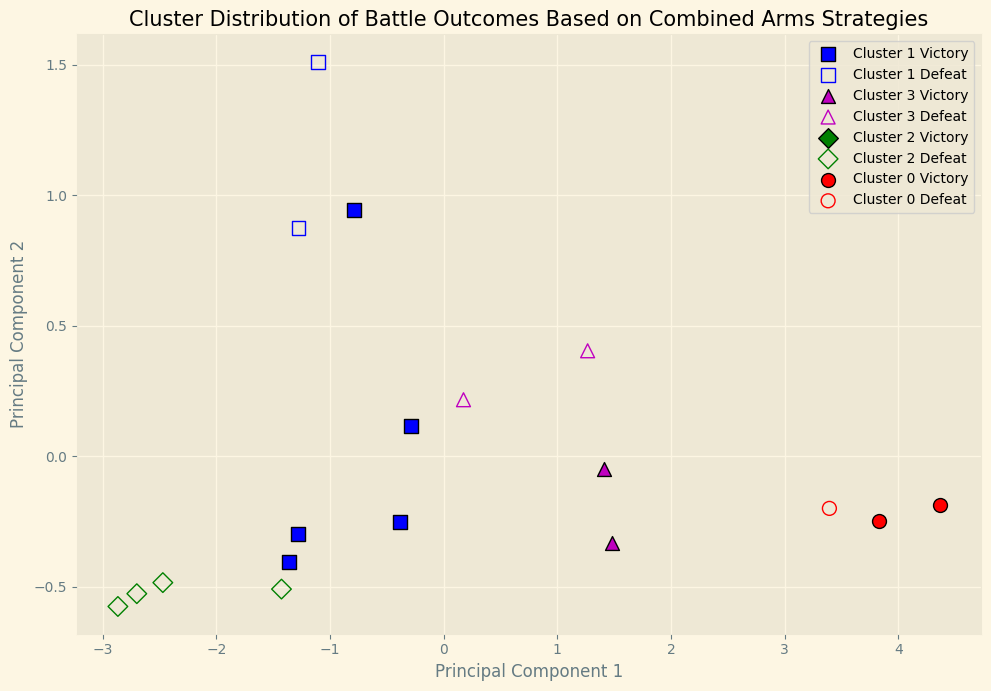What strategy is most frequently associated with victories in Cluster 0? The scatter plot markers and colors show us the distribution of outcomes across clusters. To answer, we examine which strategy is associated with the Cluster 0 Victory markers (ferrous color with solid markers in the example). By checking the cluster's markers, it is apparent.
Answer: Maneuver Warfare Which cluster contains the most "Defeat" outcomes? By visually comparing the number of 'Defeat' markers (those with white centers) in each cluster, we identify that some clusters have more 'Defeat' outcomes than others. The specific count can be observed from the visual plot distribution.
Answer: Cluster 3 What is the relationship between principal components for victories in Strategy "Maneuver Warfare"? To determine the relationship, look at the positions of Maneuver Warfare victory markers. Markers for "Maneuver Warfare" have specific positions in the PCA plot, showing how they align along the two principal components. This can suggest tendencies or clusters that align victories with this strategy.
Answer: Clustering towards higher principal component 1 Compare the number of victories associated with "Frontal Assault" to those with "Defensive Stand". By comparing visual markers for both strategies and tallying their count with their respective outcomes, particularly looking at the scatter plot for 'Victory' markers.
Answer: Frontal Assault has more victories What color indicates the dominant strategy cluster involving "Guerrilla Tactics"? Identify the color associated with the cluster containing the majority of "Guerrilla Tactics" markers, focusing on their cluster colors in the PCA plot.
Answer: Color blue How do the "Defeat" outcomes in the "Breakthrough" strategy compare across principal components? Check the plot for the specific markers assigned to "Breakthrough" strategy 'Defeat' outcomes, noting their positions along the principal component axes. This correlates the spread of these outcomes.
Answer: Spread out across principal component 1 and 2 Is there any cluster with mixed outcomes for "Encirclement" strategy and which one? Determine which, if any, clusters contain both 'Victory' and 'Defeat' markers for the "Encirclement" strategy by analyzing the cluster-wise distribution of outcomes.
Answer: Cluster 2 Do victories in "Maneuver Warfare" occupy a distinct area in the PCA plot compared to defeats? Compare the spatial arrangement of 'Victory' markers to 'Defeat' markers for "Maneuver Warfare" in the PCA plot, noting clustering tendencies and overlaps or separations.
Answer: Yes, distinctively higher Which principal component shows more variance for victories in "Defensive Stand"? Observe the concentration and spread of 'Victory' markers for the "Defensive Stand" strategy along the axes of principal components to identify which component shows a greater range of variance.
Answer: Principal Component 2 What is the noticeable pattern in outcomes for "Frontal Assault" strategy in the PCA plot? By examining the markers representing "Frontal Assault" in the PCA plot, note if there are any visible clustering tendencies or distribution patterns distinctively denoting victory or defeat.
Answer: Clusters indicating more victories than defeats but not highly concentrated 